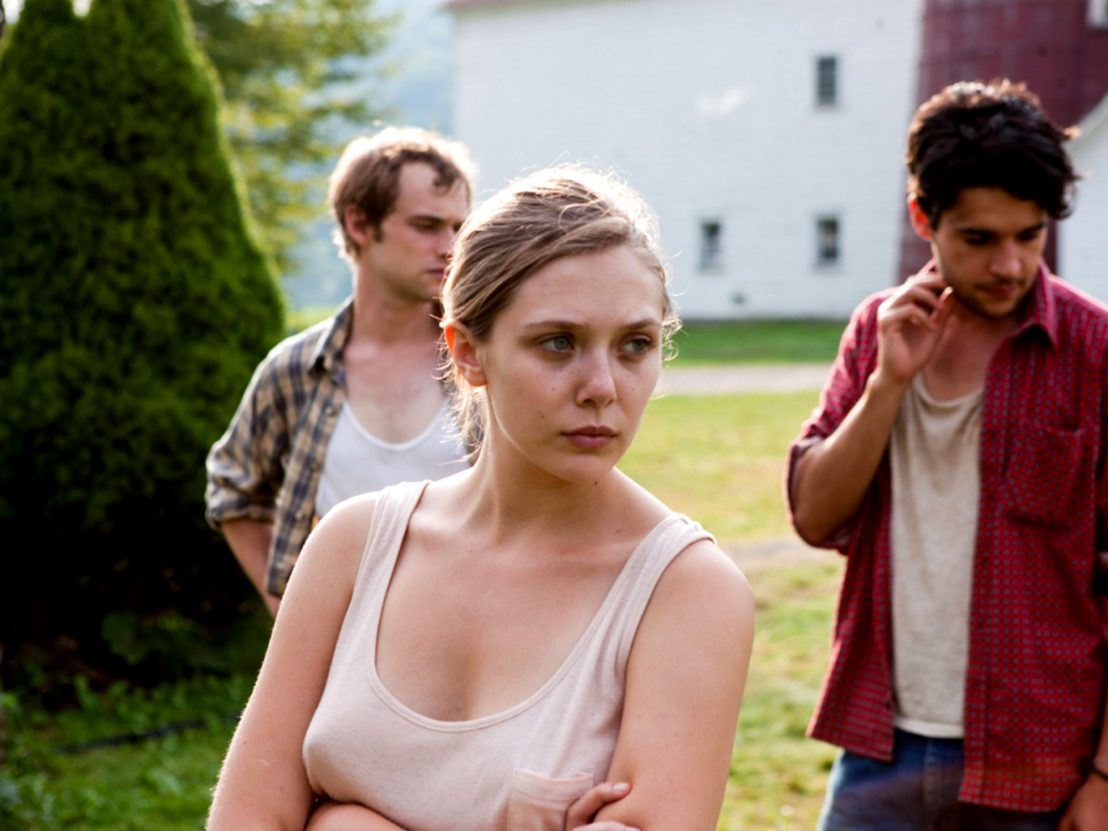If you could step into this scene, what would you say or do? If stepping into this scene, I would approach the characters with a calm and empathetic demeanor. Addressing the woman at the center, I might say, 'It seems like something serious is weighing on you all. Sometimes sharing can help lighten the burden. Is there a way I can assist or provide support?' This approach acknowledges their distress while offering a helping hand, creating a bridge of understanding and potentially opening up a dialogue for them to express their concerns. 